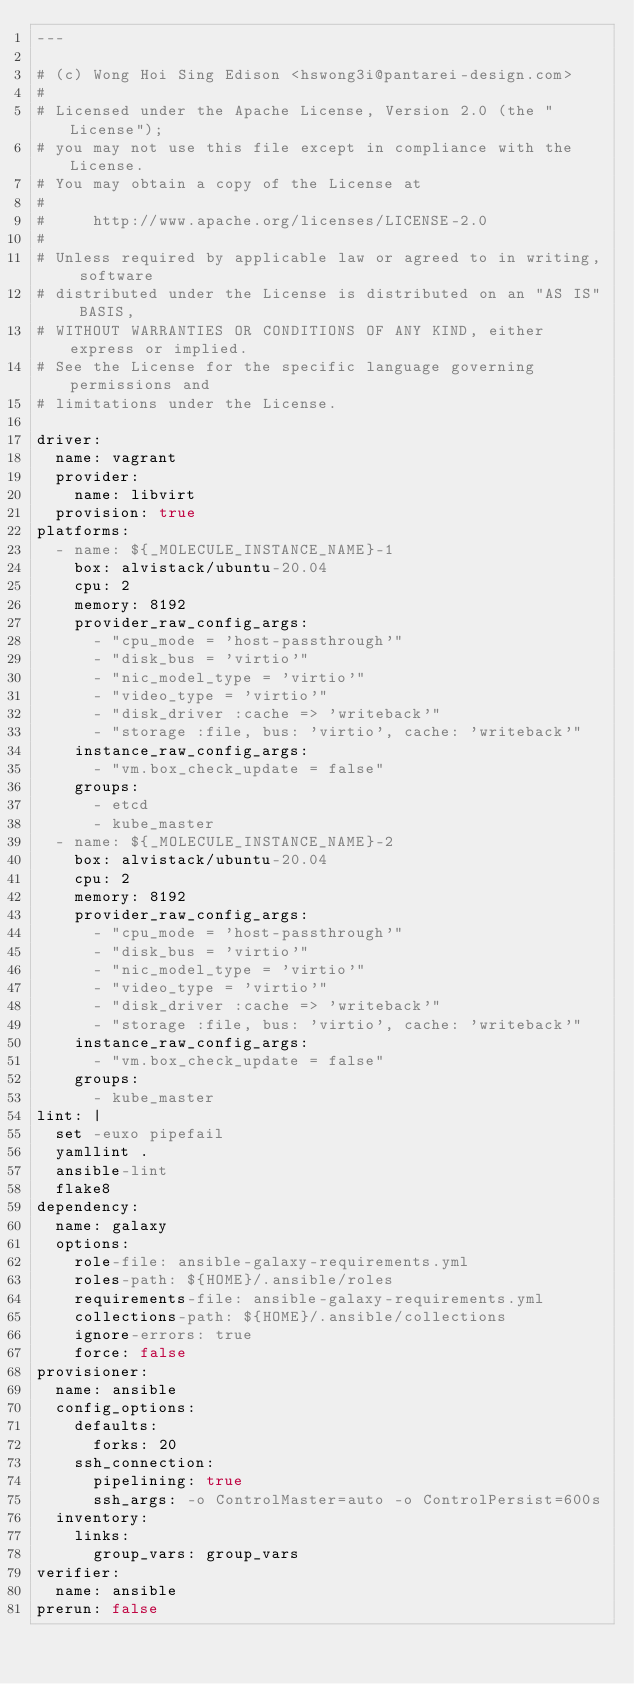Convert code to text. <code><loc_0><loc_0><loc_500><loc_500><_YAML_>---

# (c) Wong Hoi Sing Edison <hswong3i@pantarei-design.com>
#
# Licensed under the Apache License, Version 2.0 (the "License");
# you may not use this file except in compliance with the License.
# You may obtain a copy of the License at
#
#     http://www.apache.org/licenses/LICENSE-2.0
#
# Unless required by applicable law or agreed to in writing, software
# distributed under the License is distributed on an "AS IS" BASIS,
# WITHOUT WARRANTIES OR CONDITIONS OF ANY KIND, either express or implied.
# See the License for the specific language governing permissions and
# limitations under the License.

driver:
  name: vagrant
  provider:
    name: libvirt
  provision: true
platforms:
  - name: ${_MOLECULE_INSTANCE_NAME}-1
    box: alvistack/ubuntu-20.04
    cpu: 2
    memory: 8192
    provider_raw_config_args:
      - "cpu_mode = 'host-passthrough'"
      - "disk_bus = 'virtio'"
      - "nic_model_type = 'virtio'"
      - "video_type = 'virtio'"
      - "disk_driver :cache => 'writeback'"
      - "storage :file, bus: 'virtio', cache: 'writeback'"
    instance_raw_config_args:
      - "vm.box_check_update = false"
    groups:
      - etcd
      - kube_master
  - name: ${_MOLECULE_INSTANCE_NAME}-2
    box: alvistack/ubuntu-20.04
    cpu: 2
    memory: 8192
    provider_raw_config_args:
      - "cpu_mode = 'host-passthrough'"
      - "disk_bus = 'virtio'"
      - "nic_model_type = 'virtio'"
      - "video_type = 'virtio'"
      - "disk_driver :cache => 'writeback'"
      - "storage :file, bus: 'virtio', cache: 'writeback'"
    instance_raw_config_args:
      - "vm.box_check_update = false"
    groups:
      - kube_master
lint: |
  set -euxo pipefail
  yamllint .
  ansible-lint
  flake8
dependency:
  name: galaxy
  options:
    role-file: ansible-galaxy-requirements.yml
    roles-path: ${HOME}/.ansible/roles
    requirements-file: ansible-galaxy-requirements.yml
    collections-path: ${HOME}/.ansible/collections
    ignore-errors: true
    force: false
provisioner:
  name: ansible
  config_options:
    defaults:
      forks: 20
    ssh_connection:
      pipelining: true
      ssh_args: -o ControlMaster=auto -o ControlPersist=600s
  inventory:
    links:
      group_vars: group_vars
verifier:
  name: ansible
prerun: false
</code> 